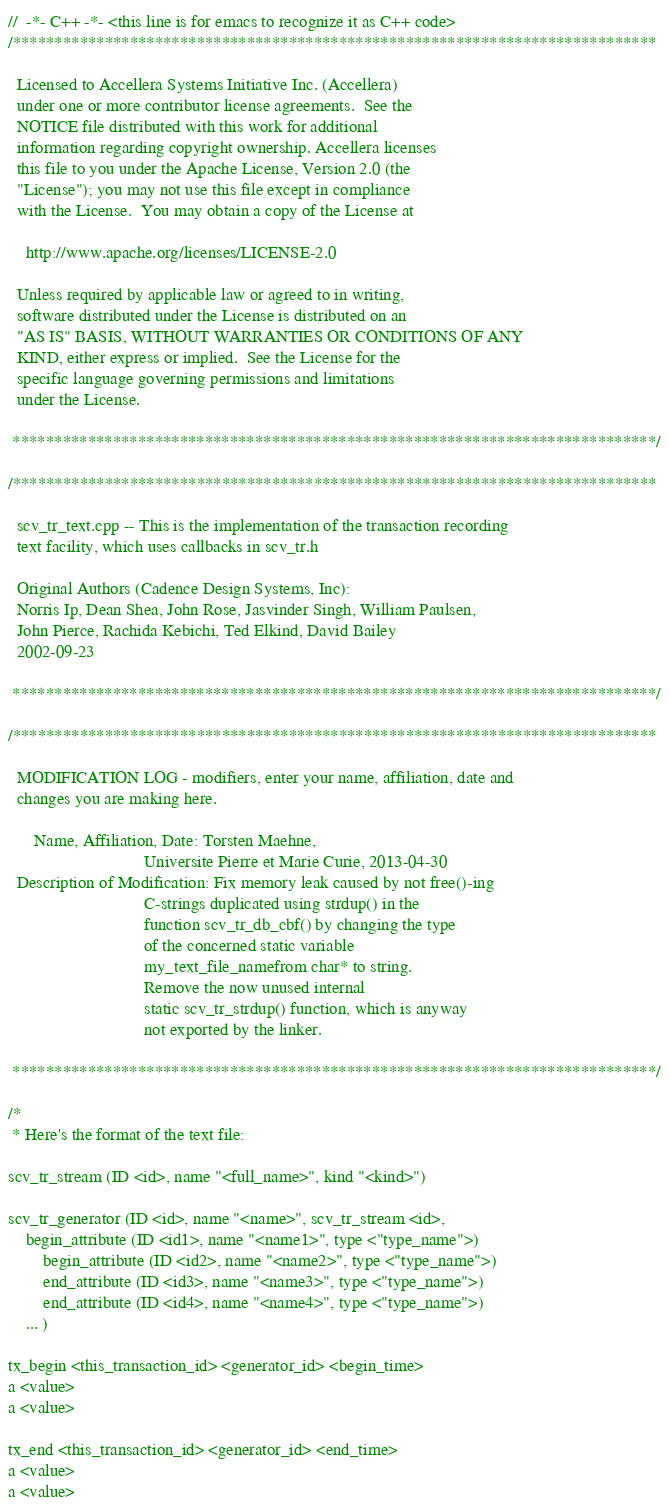<code> <loc_0><loc_0><loc_500><loc_500><_C++_>//  -*- C++ -*- <this line is for emacs to recognize it as C++ code>
/*****************************************************************************

  Licensed to Accellera Systems Initiative Inc. (Accellera) 
  under one or more contributor license agreements.  See the 
  NOTICE file distributed with this work for additional 
  information regarding copyright ownership. Accellera licenses 
  this file to you under the Apache License, Version 2.0 (the
  "License"); you may not use this file except in compliance
  with the License.  You may obtain a copy of the License at
 
    http://www.apache.org/licenses/LICENSE-2.0
 
  Unless required by applicable law or agreed to in writing,
  software distributed under the License is distributed on an
  "AS IS" BASIS, WITHOUT WARRANTIES OR CONDITIONS OF ANY
  KIND, either express or implied.  See the License for the
  specific language governing permissions and limitations
  under the License.

 *****************************************************************************/

/*****************************************************************************

  scv_tr_text.cpp -- This is the implementation of the transaction recording
  text facility, which uses callbacks in scv_tr.h

  Original Authors (Cadence Design Systems, Inc):
  Norris Ip, Dean Shea, John Rose, Jasvinder Singh, William Paulsen,
  John Pierce, Rachida Kebichi, Ted Elkind, David Bailey
  2002-09-23

 *****************************************************************************/

/*****************************************************************************

  MODIFICATION LOG - modifiers, enter your name, affiliation, date and
  changes you are making here.

      Name, Affiliation, Date: Torsten Maehne,
                               Universite Pierre et Marie Curie, 2013-04-30
  Description of Modification: Fix memory leak caused by not free()-ing
                               C-strings duplicated using strdup() in the
                               function scv_tr_db_cbf() by changing the type
                               of the concerned static variable
                               my_text_file_namefrom char* to string.
                               Remove the now unused internal
                               static scv_tr_strdup() function, which is anyway
                               not exported by the linker.

 *****************************************************************************/

/*
 * Here's the format of the text file:

scv_tr_stream (ID <id>, name "<full_name>", kind "<kind>")

scv_tr_generator (ID <id>, name "<name>", scv_tr_stream <id>,
	begin_attribute (ID <id1>, name "<name1>", type <"type_name">)
        begin_attribute (ID <id2>, name "<name2>", type <"type_name">)
        end_attribute (ID <id3>, name "<name3>", type <"type_name">)
        end_attribute (ID <id4>, name "<name4>", type <"type_name">)
	... )

tx_begin <this_transaction_id> <generator_id> <begin_time>
a <value> 
a <value>

tx_end <this_transaction_id> <generator_id> <end_time>
a <value>
a <value>
</code> 